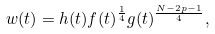<formula> <loc_0><loc_0><loc_500><loc_500>w ( t ) = h ( t ) f ( t ) ^ { \frac { 1 } { 4 } } g ( t ) ^ { \frac { N - 2 p - 1 } { 4 } } ,</formula> 